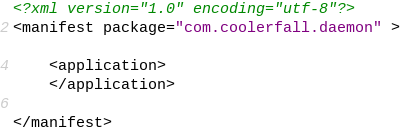<code> <loc_0><loc_0><loc_500><loc_500><_XML_><?xml version="1.0" encoding="utf-8"?>
<manifest package="com.coolerfall.daemon" >

    <application>
    </application>

</manifest>
</code> 